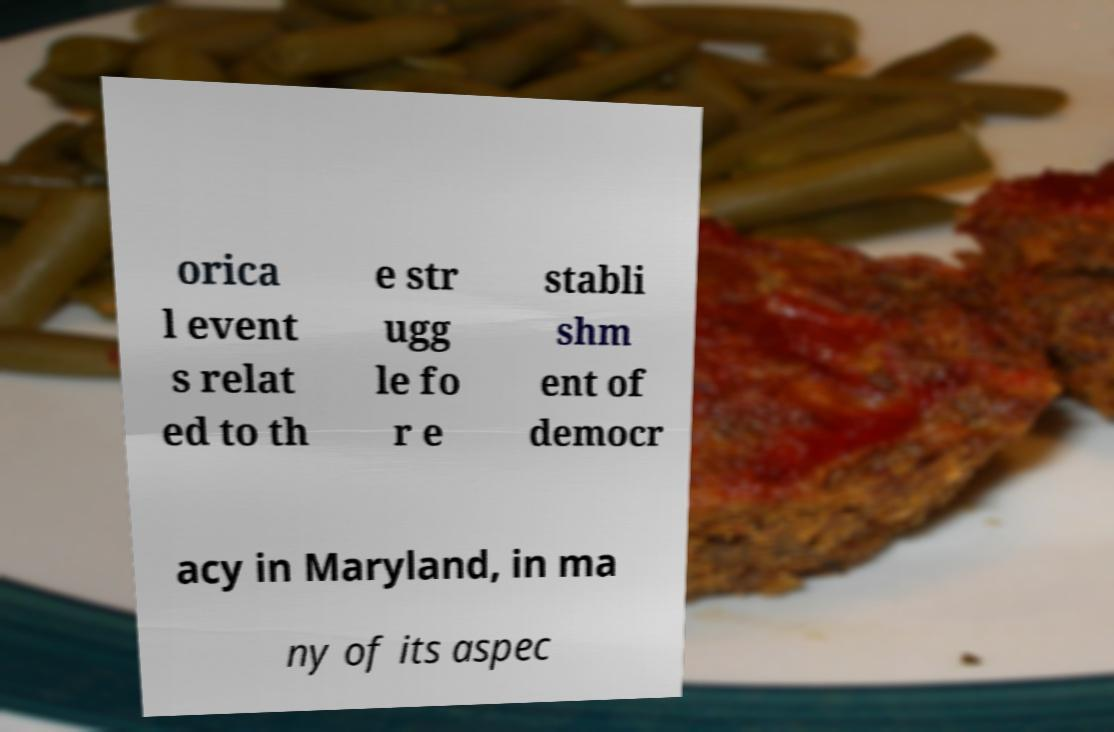Could you extract and type out the text from this image? orica l event s relat ed to th e str ugg le fo r e stabli shm ent of democr acy in Maryland, in ma ny of its aspec 